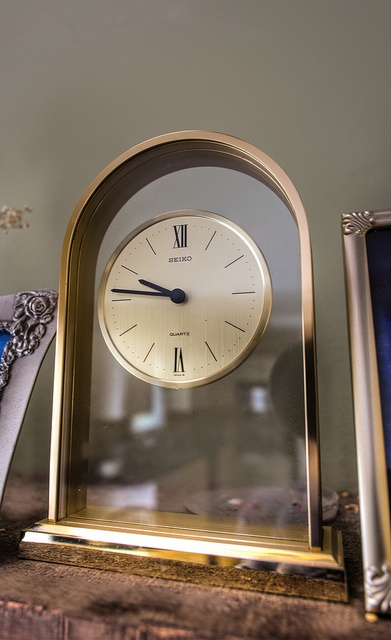Describe the objects in this image and their specific colors. I can see a clock in gray and tan tones in this image. 